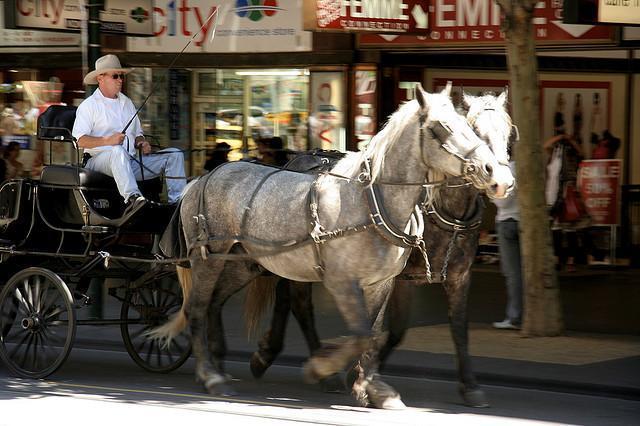How many horses are pulling the cart?
Give a very brief answer. 2. How many people are in the photo?
Give a very brief answer. 2. How many horses are visible?
Give a very brief answer. 2. 